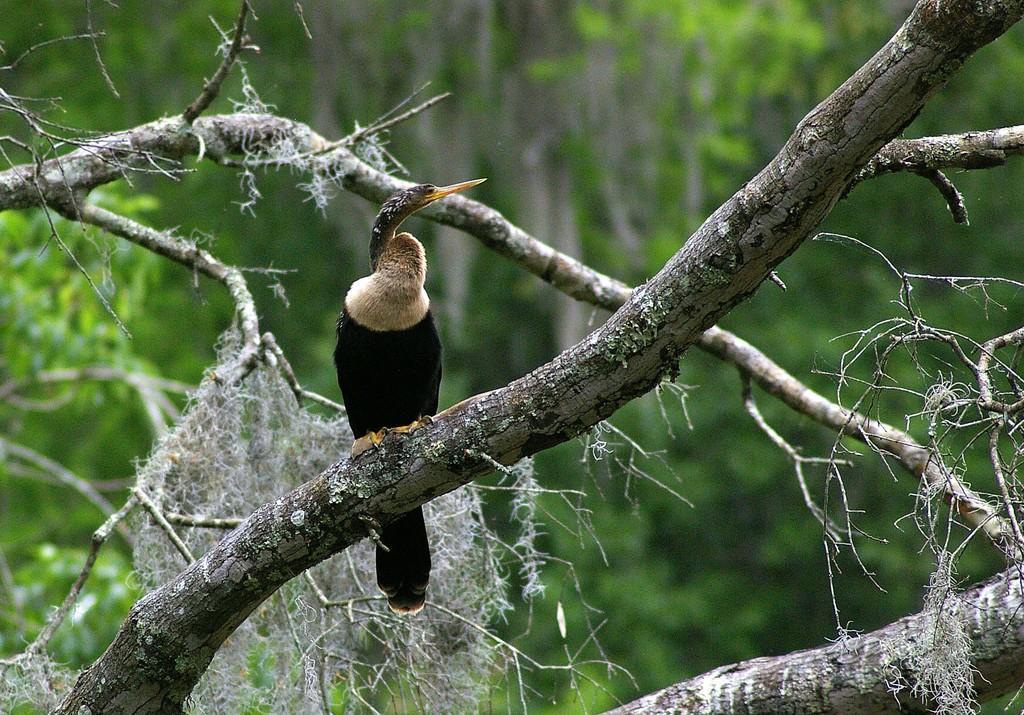Describe this image in one or two sentences. In this image we can see a bird on the stem of a tree. In the background of the image there are trees. 